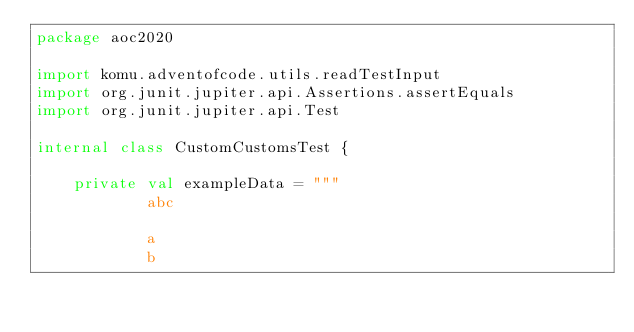Convert code to text. <code><loc_0><loc_0><loc_500><loc_500><_Kotlin_>package aoc2020

import komu.adventofcode.utils.readTestInput
import org.junit.jupiter.api.Assertions.assertEquals
import org.junit.jupiter.api.Test

internal class CustomCustomsTest {

    private val exampleData = """
            abc

            a
            b</code> 